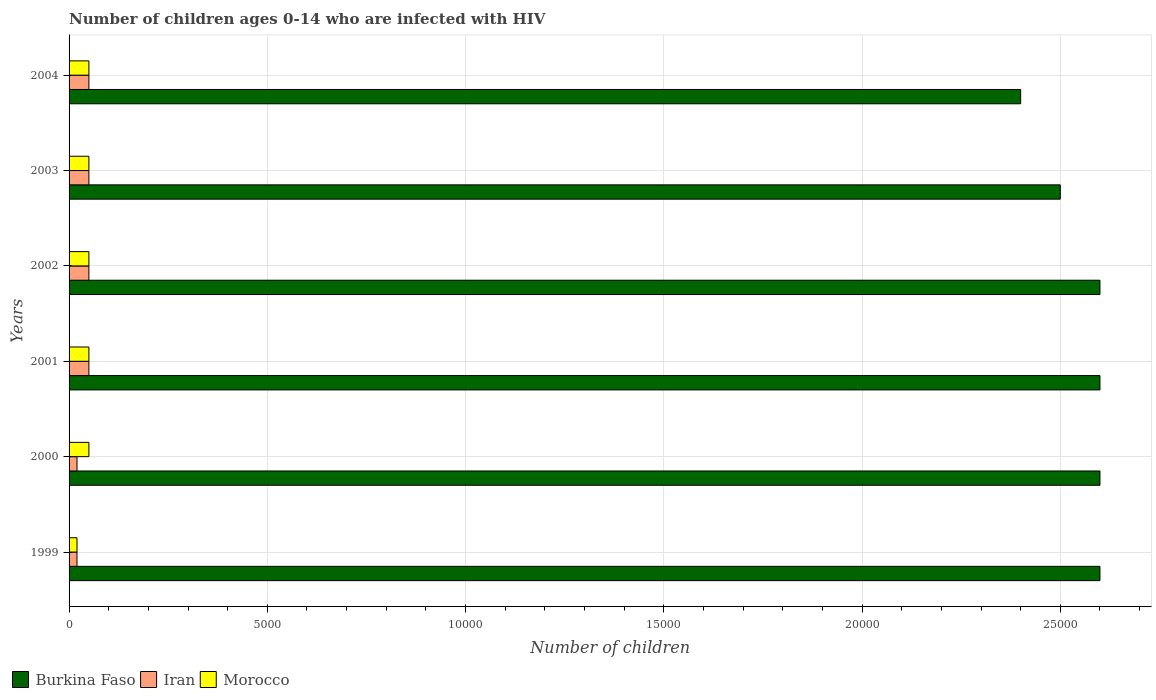Are the number of bars per tick equal to the number of legend labels?
Give a very brief answer. Yes. Are the number of bars on each tick of the Y-axis equal?
Provide a short and direct response. Yes. What is the label of the 2nd group of bars from the top?
Your response must be concise. 2003. In how many cases, is the number of bars for a given year not equal to the number of legend labels?
Provide a short and direct response. 0. What is the number of HIV infected children in Iran in 2000?
Give a very brief answer. 200. Across all years, what is the maximum number of HIV infected children in Burkina Faso?
Offer a very short reply. 2.60e+04. Across all years, what is the minimum number of HIV infected children in Morocco?
Offer a terse response. 200. In which year was the number of HIV infected children in Morocco maximum?
Provide a short and direct response. 2000. What is the total number of HIV infected children in Iran in the graph?
Offer a terse response. 2400. What is the difference between the number of HIV infected children in Iran in 2004 and the number of HIV infected children in Burkina Faso in 1999?
Offer a terse response. -2.55e+04. What is the average number of HIV infected children in Burkina Faso per year?
Your answer should be compact. 2.55e+04. Is the difference between the number of HIV infected children in Iran in 2000 and 2003 greater than the difference between the number of HIV infected children in Morocco in 2000 and 2003?
Make the answer very short. No. What is the difference between the highest and the second highest number of HIV infected children in Morocco?
Ensure brevity in your answer.  0. What is the difference between the highest and the lowest number of HIV infected children in Iran?
Your answer should be very brief. 300. What does the 3rd bar from the top in 1999 represents?
Provide a succinct answer. Burkina Faso. What does the 3rd bar from the bottom in 2000 represents?
Your response must be concise. Morocco. How many bars are there?
Your answer should be very brief. 18. How many years are there in the graph?
Offer a very short reply. 6. Are the values on the major ticks of X-axis written in scientific E-notation?
Offer a terse response. No. Where does the legend appear in the graph?
Give a very brief answer. Bottom left. What is the title of the graph?
Offer a very short reply. Number of children ages 0-14 who are infected with HIV. What is the label or title of the X-axis?
Ensure brevity in your answer.  Number of children. What is the label or title of the Y-axis?
Offer a very short reply. Years. What is the Number of children in Burkina Faso in 1999?
Ensure brevity in your answer.  2.60e+04. What is the Number of children of Burkina Faso in 2000?
Offer a terse response. 2.60e+04. What is the Number of children in Iran in 2000?
Your answer should be very brief. 200. What is the Number of children in Morocco in 2000?
Ensure brevity in your answer.  500. What is the Number of children of Burkina Faso in 2001?
Make the answer very short. 2.60e+04. What is the Number of children of Iran in 2001?
Provide a short and direct response. 500. What is the Number of children of Burkina Faso in 2002?
Provide a succinct answer. 2.60e+04. What is the Number of children in Morocco in 2002?
Provide a short and direct response. 500. What is the Number of children in Burkina Faso in 2003?
Offer a very short reply. 2.50e+04. What is the Number of children in Morocco in 2003?
Ensure brevity in your answer.  500. What is the Number of children of Burkina Faso in 2004?
Give a very brief answer. 2.40e+04. What is the Number of children of Iran in 2004?
Your answer should be very brief. 500. Across all years, what is the maximum Number of children in Burkina Faso?
Make the answer very short. 2.60e+04. Across all years, what is the minimum Number of children of Burkina Faso?
Ensure brevity in your answer.  2.40e+04. Across all years, what is the minimum Number of children of Iran?
Ensure brevity in your answer.  200. What is the total Number of children of Burkina Faso in the graph?
Your response must be concise. 1.53e+05. What is the total Number of children of Iran in the graph?
Your response must be concise. 2400. What is the total Number of children in Morocco in the graph?
Provide a short and direct response. 2700. What is the difference between the Number of children of Burkina Faso in 1999 and that in 2000?
Give a very brief answer. 0. What is the difference between the Number of children in Iran in 1999 and that in 2000?
Give a very brief answer. 0. What is the difference between the Number of children in Morocco in 1999 and that in 2000?
Offer a terse response. -300. What is the difference between the Number of children of Burkina Faso in 1999 and that in 2001?
Offer a terse response. 0. What is the difference between the Number of children of Iran in 1999 and that in 2001?
Provide a succinct answer. -300. What is the difference between the Number of children in Morocco in 1999 and that in 2001?
Provide a short and direct response. -300. What is the difference between the Number of children in Burkina Faso in 1999 and that in 2002?
Ensure brevity in your answer.  0. What is the difference between the Number of children of Iran in 1999 and that in 2002?
Ensure brevity in your answer.  -300. What is the difference between the Number of children in Morocco in 1999 and that in 2002?
Keep it short and to the point. -300. What is the difference between the Number of children in Iran in 1999 and that in 2003?
Your response must be concise. -300. What is the difference between the Number of children of Morocco in 1999 and that in 2003?
Ensure brevity in your answer.  -300. What is the difference between the Number of children of Burkina Faso in 1999 and that in 2004?
Your answer should be very brief. 2000. What is the difference between the Number of children in Iran in 1999 and that in 2004?
Your answer should be very brief. -300. What is the difference between the Number of children in Morocco in 1999 and that in 2004?
Ensure brevity in your answer.  -300. What is the difference between the Number of children of Burkina Faso in 2000 and that in 2001?
Give a very brief answer. 0. What is the difference between the Number of children in Iran in 2000 and that in 2001?
Your answer should be compact. -300. What is the difference between the Number of children of Morocco in 2000 and that in 2001?
Ensure brevity in your answer.  0. What is the difference between the Number of children of Iran in 2000 and that in 2002?
Provide a short and direct response. -300. What is the difference between the Number of children in Burkina Faso in 2000 and that in 2003?
Keep it short and to the point. 1000. What is the difference between the Number of children of Iran in 2000 and that in 2003?
Provide a short and direct response. -300. What is the difference between the Number of children of Burkina Faso in 2000 and that in 2004?
Your response must be concise. 2000. What is the difference between the Number of children of Iran in 2000 and that in 2004?
Ensure brevity in your answer.  -300. What is the difference between the Number of children of Iran in 2001 and that in 2002?
Your response must be concise. 0. What is the difference between the Number of children of Morocco in 2001 and that in 2002?
Keep it short and to the point. 0. What is the difference between the Number of children of Burkina Faso in 2001 and that in 2003?
Make the answer very short. 1000. What is the difference between the Number of children of Morocco in 2001 and that in 2003?
Offer a very short reply. 0. What is the difference between the Number of children in Morocco in 2002 and that in 2004?
Offer a terse response. 0. What is the difference between the Number of children in Burkina Faso in 2003 and that in 2004?
Your answer should be very brief. 1000. What is the difference between the Number of children in Morocco in 2003 and that in 2004?
Offer a very short reply. 0. What is the difference between the Number of children of Burkina Faso in 1999 and the Number of children of Iran in 2000?
Make the answer very short. 2.58e+04. What is the difference between the Number of children of Burkina Faso in 1999 and the Number of children of Morocco in 2000?
Your answer should be very brief. 2.55e+04. What is the difference between the Number of children of Iran in 1999 and the Number of children of Morocco in 2000?
Your answer should be very brief. -300. What is the difference between the Number of children of Burkina Faso in 1999 and the Number of children of Iran in 2001?
Give a very brief answer. 2.55e+04. What is the difference between the Number of children of Burkina Faso in 1999 and the Number of children of Morocco in 2001?
Give a very brief answer. 2.55e+04. What is the difference between the Number of children of Iran in 1999 and the Number of children of Morocco in 2001?
Offer a terse response. -300. What is the difference between the Number of children of Burkina Faso in 1999 and the Number of children of Iran in 2002?
Offer a terse response. 2.55e+04. What is the difference between the Number of children in Burkina Faso in 1999 and the Number of children in Morocco in 2002?
Give a very brief answer. 2.55e+04. What is the difference between the Number of children in Iran in 1999 and the Number of children in Morocco in 2002?
Your answer should be compact. -300. What is the difference between the Number of children of Burkina Faso in 1999 and the Number of children of Iran in 2003?
Offer a very short reply. 2.55e+04. What is the difference between the Number of children in Burkina Faso in 1999 and the Number of children in Morocco in 2003?
Keep it short and to the point. 2.55e+04. What is the difference between the Number of children of Iran in 1999 and the Number of children of Morocco in 2003?
Provide a short and direct response. -300. What is the difference between the Number of children in Burkina Faso in 1999 and the Number of children in Iran in 2004?
Make the answer very short. 2.55e+04. What is the difference between the Number of children of Burkina Faso in 1999 and the Number of children of Morocco in 2004?
Provide a succinct answer. 2.55e+04. What is the difference between the Number of children in Iran in 1999 and the Number of children in Morocco in 2004?
Keep it short and to the point. -300. What is the difference between the Number of children in Burkina Faso in 2000 and the Number of children in Iran in 2001?
Offer a very short reply. 2.55e+04. What is the difference between the Number of children in Burkina Faso in 2000 and the Number of children in Morocco in 2001?
Ensure brevity in your answer.  2.55e+04. What is the difference between the Number of children of Iran in 2000 and the Number of children of Morocco in 2001?
Keep it short and to the point. -300. What is the difference between the Number of children in Burkina Faso in 2000 and the Number of children in Iran in 2002?
Give a very brief answer. 2.55e+04. What is the difference between the Number of children of Burkina Faso in 2000 and the Number of children of Morocco in 2002?
Offer a very short reply. 2.55e+04. What is the difference between the Number of children of Iran in 2000 and the Number of children of Morocco in 2002?
Provide a short and direct response. -300. What is the difference between the Number of children of Burkina Faso in 2000 and the Number of children of Iran in 2003?
Your answer should be very brief. 2.55e+04. What is the difference between the Number of children in Burkina Faso in 2000 and the Number of children in Morocco in 2003?
Keep it short and to the point. 2.55e+04. What is the difference between the Number of children in Iran in 2000 and the Number of children in Morocco in 2003?
Provide a succinct answer. -300. What is the difference between the Number of children in Burkina Faso in 2000 and the Number of children in Iran in 2004?
Your response must be concise. 2.55e+04. What is the difference between the Number of children in Burkina Faso in 2000 and the Number of children in Morocco in 2004?
Your answer should be compact. 2.55e+04. What is the difference between the Number of children in Iran in 2000 and the Number of children in Morocco in 2004?
Your answer should be very brief. -300. What is the difference between the Number of children of Burkina Faso in 2001 and the Number of children of Iran in 2002?
Ensure brevity in your answer.  2.55e+04. What is the difference between the Number of children of Burkina Faso in 2001 and the Number of children of Morocco in 2002?
Offer a very short reply. 2.55e+04. What is the difference between the Number of children in Burkina Faso in 2001 and the Number of children in Iran in 2003?
Your answer should be very brief. 2.55e+04. What is the difference between the Number of children in Burkina Faso in 2001 and the Number of children in Morocco in 2003?
Offer a very short reply. 2.55e+04. What is the difference between the Number of children in Iran in 2001 and the Number of children in Morocco in 2003?
Your answer should be compact. 0. What is the difference between the Number of children of Burkina Faso in 2001 and the Number of children of Iran in 2004?
Your response must be concise. 2.55e+04. What is the difference between the Number of children of Burkina Faso in 2001 and the Number of children of Morocco in 2004?
Offer a very short reply. 2.55e+04. What is the difference between the Number of children of Burkina Faso in 2002 and the Number of children of Iran in 2003?
Offer a terse response. 2.55e+04. What is the difference between the Number of children in Burkina Faso in 2002 and the Number of children in Morocco in 2003?
Provide a short and direct response. 2.55e+04. What is the difference between the Number of children of Iran in 2002 and the Number of children of Morocco in 2003?
Keep it short and to the point. 0. What is the difference between the Number of children in Burkina Faso in 2002 and the Number of children in Iran in 2004?
Your response must be concise. 2.55e+04. What is the difference between the Number of children of Burkina Faso in 2002 and the Number of children of Morocco in 2004?
Keep it short and to the point. 2.55e+04. What is the difference between the Number of children of Iran in 2002 and the Number of children of Morocco in 2004?
Make the answer very short. 0. What is the difference between the Number of children in Burkina Faso in 2003 and the Number of children in Iran in 2004?
Keep it short and to the point. 2.45e+04. What is the difference between the Number of children in Burkina Faso in 2003 and the Number of children in Morocco in 2004?
Offer a terse response. 2.45e+04. What is the average Number of children of Burkina Faso per year?
Provide a short and direct response. 2.55e+04. What is the average Number of children of Morocco per year?
Provide a short and direct response. 450. In the year 1999, what is the difference between the Number of children in Burkina Faso and Number of children in Iran?
Make the answer very short. 2.58e+04. In the year 1999, what is the difference between the Number of children in Burkina Faso and Number of children in Morocco?
Keep it short and to the point. 2.58e+04. In the year 1999, what is the difference between the Number of children of Iran and Number of children of Morocco?
Provide a succinct answer. 0. In the year 2000, what is the difference between the Number of children in Burkina Faso and Number of children in Iran?
Your answer should be compact. 2.58e+04. In the year 2000, what is the difference between the Number of children in Burkina Faso and Number of children in Morocco?
Provide a succinct answer. 2.55e+04. In the year 2000, what is the difference between the Number of children of Iran and Number of children of Morocco?
Offer a very short reply. -300. In the year 2001, what is the difference between the Number of children in Burkina Faso and Number of children in Iran?
Give a very brief answer. 2.55e+04. In the year 2001, what is the difference between the Number of children in Burkina Faso and Number of children in Morocco?
Provide a succinct answer. 2.55e+04. In the year 2001, what is the difference between the Number of children of Iran and Number of children of Morocco?
Make the answer very short. 0. In the year 2002, what is the difference between the Number of children of Burkina Faso and Number of children of Iran?
Your response must be concise. 2.55e+04. In the year 2002, what is the difference between the Number of children of Burkina Faso and Number of children of Morocco?
Provide a succinct answer. 2.55e+04. In the year 2003, what is the difference between the Number of children in Burkina Faso and Number of children in Iran?
Your answer should be compact. 2.45e+04. In the year 2003, what is the difference between the Number of children in Burkina Faso and Number of children in Morocco?
Make the answer very short. 2.45e+04. In the year 2004, what is the difference between the Number of children of Burkina Faso and Number of children of Iran?
Provide a succinct answer. 2.35e+04. In the year 2004, what is the difference between the Number of children of Burkina Faso and Number of children of Morocco?
Make the answer very short. 2.35e+04. What is the ratio of the Number of children of Morocco in 1999 to that in 2000?
Offer a terse response. 0.4. What is the ratio of the Number of children in Burkina Faso in 1999 to that in 2001?
Your answer should be very brief. 1. What is the ratio of the Number of children in Iran in 1999 to that in 2001?
Give a very brief answer. 0.4. What is the ratio of the Number of children in Morocco in 1999 to that in 2001?
Your answer should be very brief. 0.4. What is the ratio of the Number of children in Morocco in 1999 to that in 2002?
Your answer should be compact. 0.4. What is the ratio of the Number of children of Iran in 1999 to that in 2003?
Make the answer very short. 0.4. What is the ratio of the Number of children of Morocco in 1999 to that in 2003?
Give a very brief answer. 0.4. What is the ratio of the Number of children in Morocco in 1999 to that in 2004?
Provide a succinct answer. 0.4. What is the ratio of the Number of children of Burkina Faso in 2000 to that in 2001?
Offer a very short reply. 1. What is the ratio of the Number of children of Iran in 2000 to that in 2001?
Ensure brevity in your answer.  0.4. What is the ratio of the Number of children of Burkina Faso in 2000 to that in 2002?
Give a very brief answer. 1. What is the ratio of the Number of children in Morocco in 2000 to that in 2002?
Provide a short and direct response. 1. What is the ratio of the Number of children in Iran in 2000 to that in 2003?
Your answer should be very brief. 0.4. What is the ratio of the Number of children in Iran in 2000 to that in 2004?
Ensure brevity in your answer.  0.4. What is the ratio of the Number of children of Burkina Faso in 2001 to that in 2002?
Your answer should be very brief. 1. What is the ratio of the Number of children in Iran in 2001 to that in 2002?
Ensure brevity in your answer.  1. What is the ratio of the Number of children in Morocco in 2001 to that in 2003?
Your answer should be compact. 1. What is the ratio of the Number of children of Iran in 2001 to that in 2004?
Keep it short and to the point. 1. What is the ratio of the Number of children in Iran in 2002 to that in 2003?
Give a very brief answer. 1. What is the ratio of the Number of children in Iran in 2002 to that in 2004?
Provide a succinct answer. 1. What is the ratio of the Number of children of Burkina Faso in 2003 to that in 2004?
Provide a succinct answer. 1.04. What is the ratio of the Number of children of Morocco in 2003 to that in 2004?
Provide a short and direct response. 1. What is the difference between the highest and the second highest Number of children of Burkina Faso?
Keep it short and to the point. 0. What is the difference between the highest and the second highest Number of children of Iran?
Your answer should be very brief. 0. What is the difference between the highest and the lowest Number of children in Iran?
Your response must be concise. 300. What is the difference between the highest and the lowest Number of children of Morocco?
Provide a succinct answer. 300. 